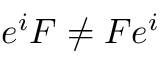<formula> <loc_0><loc_0><loc_500><loc_500>e ^ { i } F \neq F e ^ { i }</formula> 